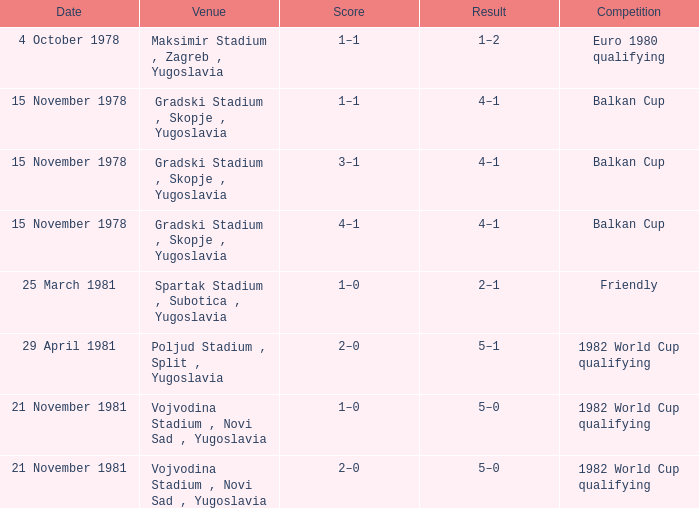What is the Result for Goal 3? 4–1. 